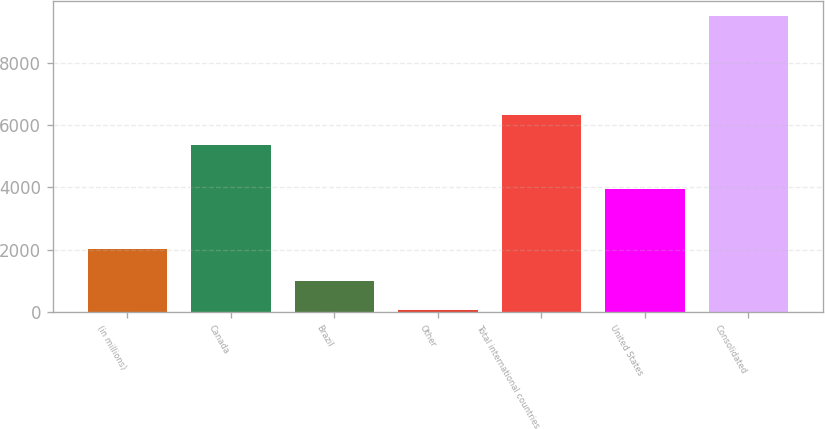Convert chart to OTSL. <chart><loc_0><loc_0><loc_500><loc_500><bar_chart><fcel>(in millions)<fcel>Canada<fcel>Brazil<fcel>Other<fcel>Total international countries<fcel>United States<fcel>Consolidated<nl><fcel>2013<fcel>5372.3<fcel>996.06<fcel>51<fcel>6317.36<fcel>3956.1<fcel>9501.6<nl></chart> 